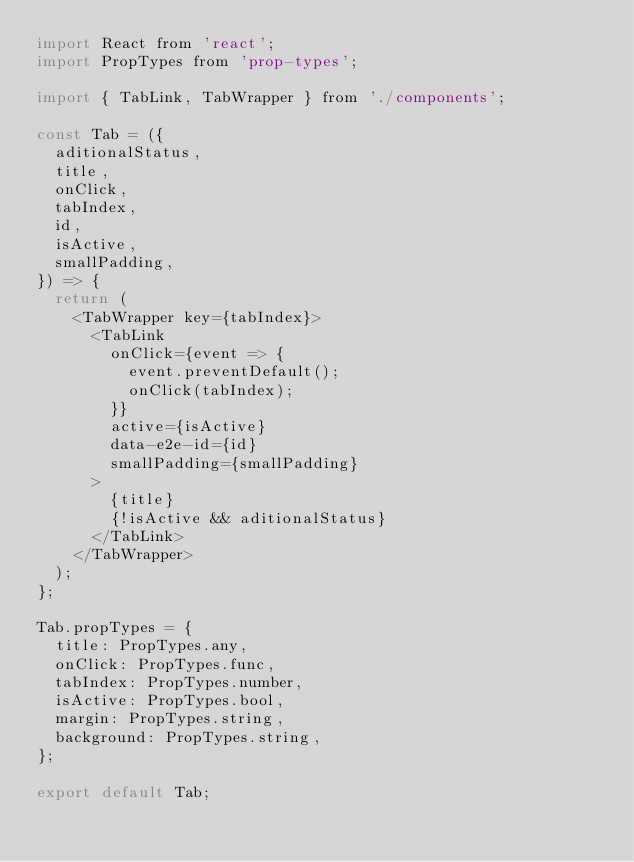<code> <loc_0><loc_0><loc_500><loc_500><_JavaScript_>import React from 'react';
import PropTypes from 'prop-types';

import { TabLink, TabWrapper } from './components';

const Tab = ({
  aditionalStatus,
  title,
  onClick,
  tabIndex,
  id,
  isActive,
  smallPadding,
}) => {
  return (
    <TabWrapper key={tabIndex}>
      <TabLink
        onClick={event => {
          event.preventDefault();
          onClick(tabIndex);
        }}
        active={isActive}
        data-e2e-id={id}
        smallPadding={smallPadding}
      >
        {title}
        {!isActive && aditionalStatus}
      </TabLink>
    </TabWrapper>
  );
};

Tab.propTypes = {
  title: PropTypes.any,
  onClick: PropTypes.func,
  tabIndex: PropTypes.number,
  isActive: PropTypes.bool,
  margin: PropTypes.string,
  background: PropTypes.string,
};

export default Tab;
</code> 